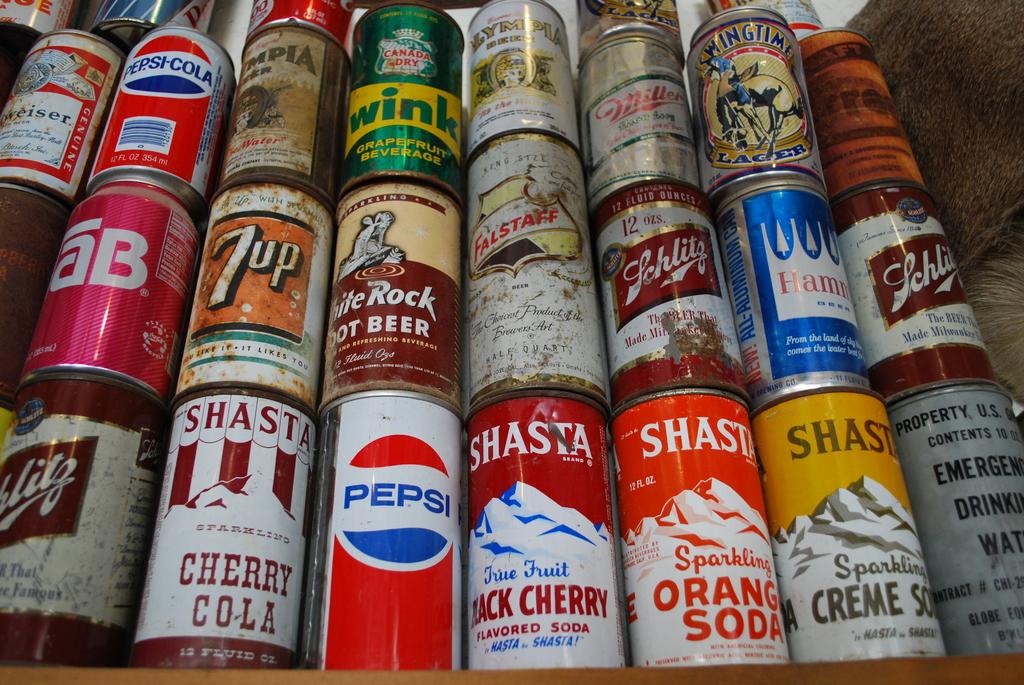What is the name of one of the sodas on the bottom row?
Offer a terse response. Pepsi. The pepsi brand?
Ensure brevity in your answer.  Not a question. 